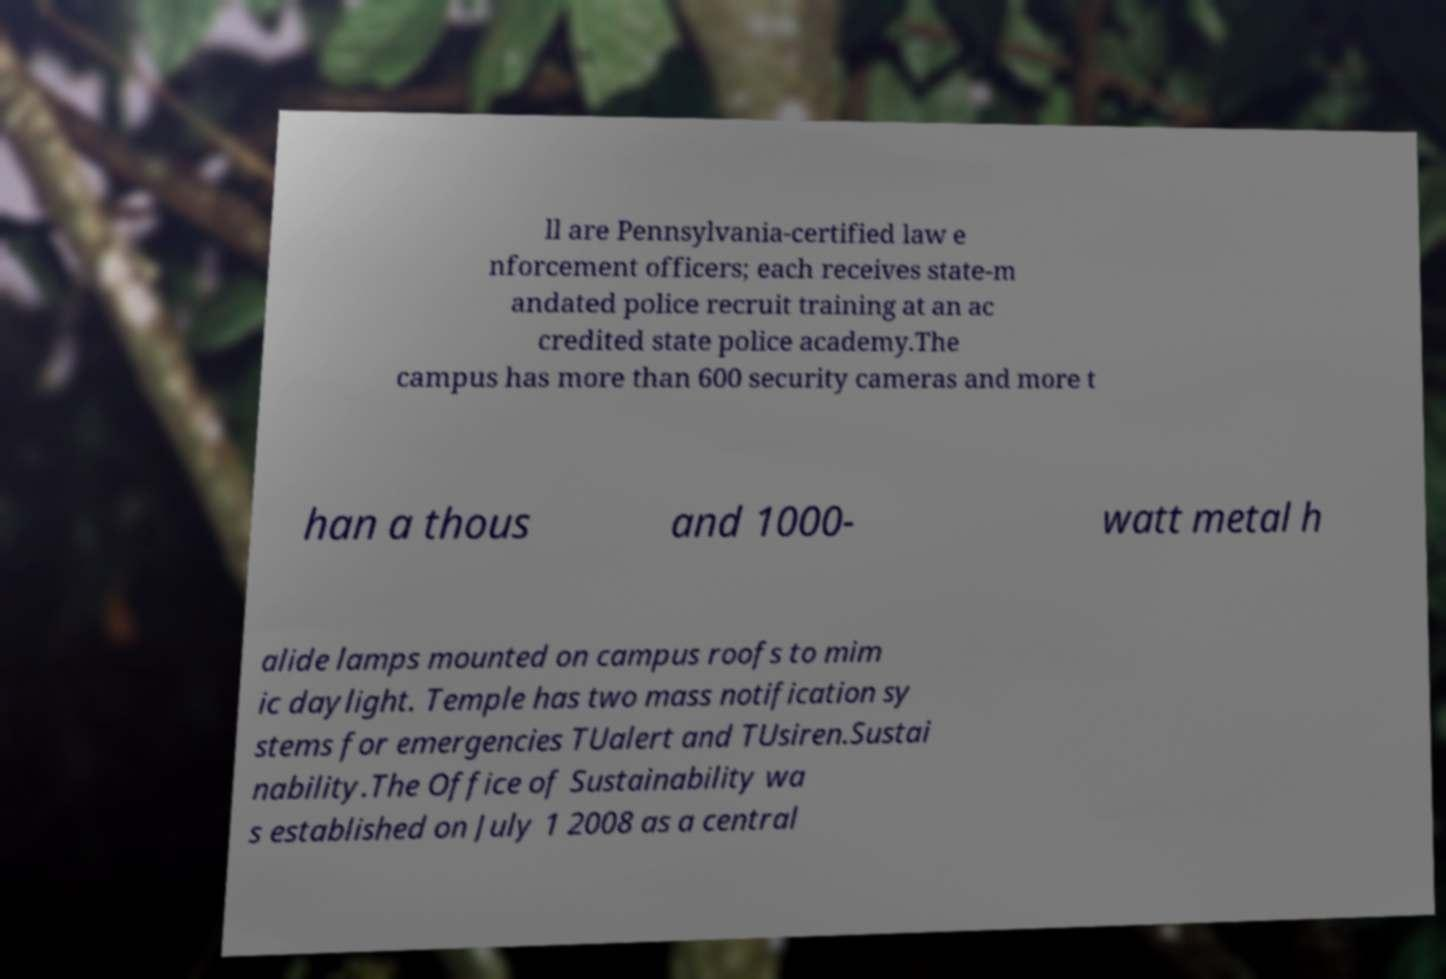Please read and relay the text visible in this image. What does it say? ll are Pennsylvania-certified law e nforcement officers; each receives state-m andated police recruit training at an ac credited state police academy.The campus has more than 600 security cameras and more t han a thous and 1000- watt metal h alide lamps mounted on campus roofs to mim ic daylight. Temple has two mass notification sy stems for emergencies TUalert and TUsiren.Sustai nability.The Office of Sustainability wa s established on July 1 2008 as a central 